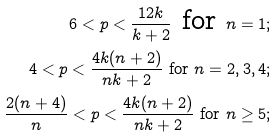Convert formula to latex. <formula><loc_0><loc_0><loc_500><loc_500>6 < p < \frac { 1 2 k } { k + 2 } \text { for } n = 1 ; \\ 4 < p < \frac { 4 k ( n + 2 ) } { n k + 2 } \text { for } n = 2 , 3 , 4 ; \\ \frac { 2 ( n + 4 ) } { n } < p < \frac { 4 k ( n + 2 ) } { n k + 2 } \text { for } n \geq 5 ;</formula> 